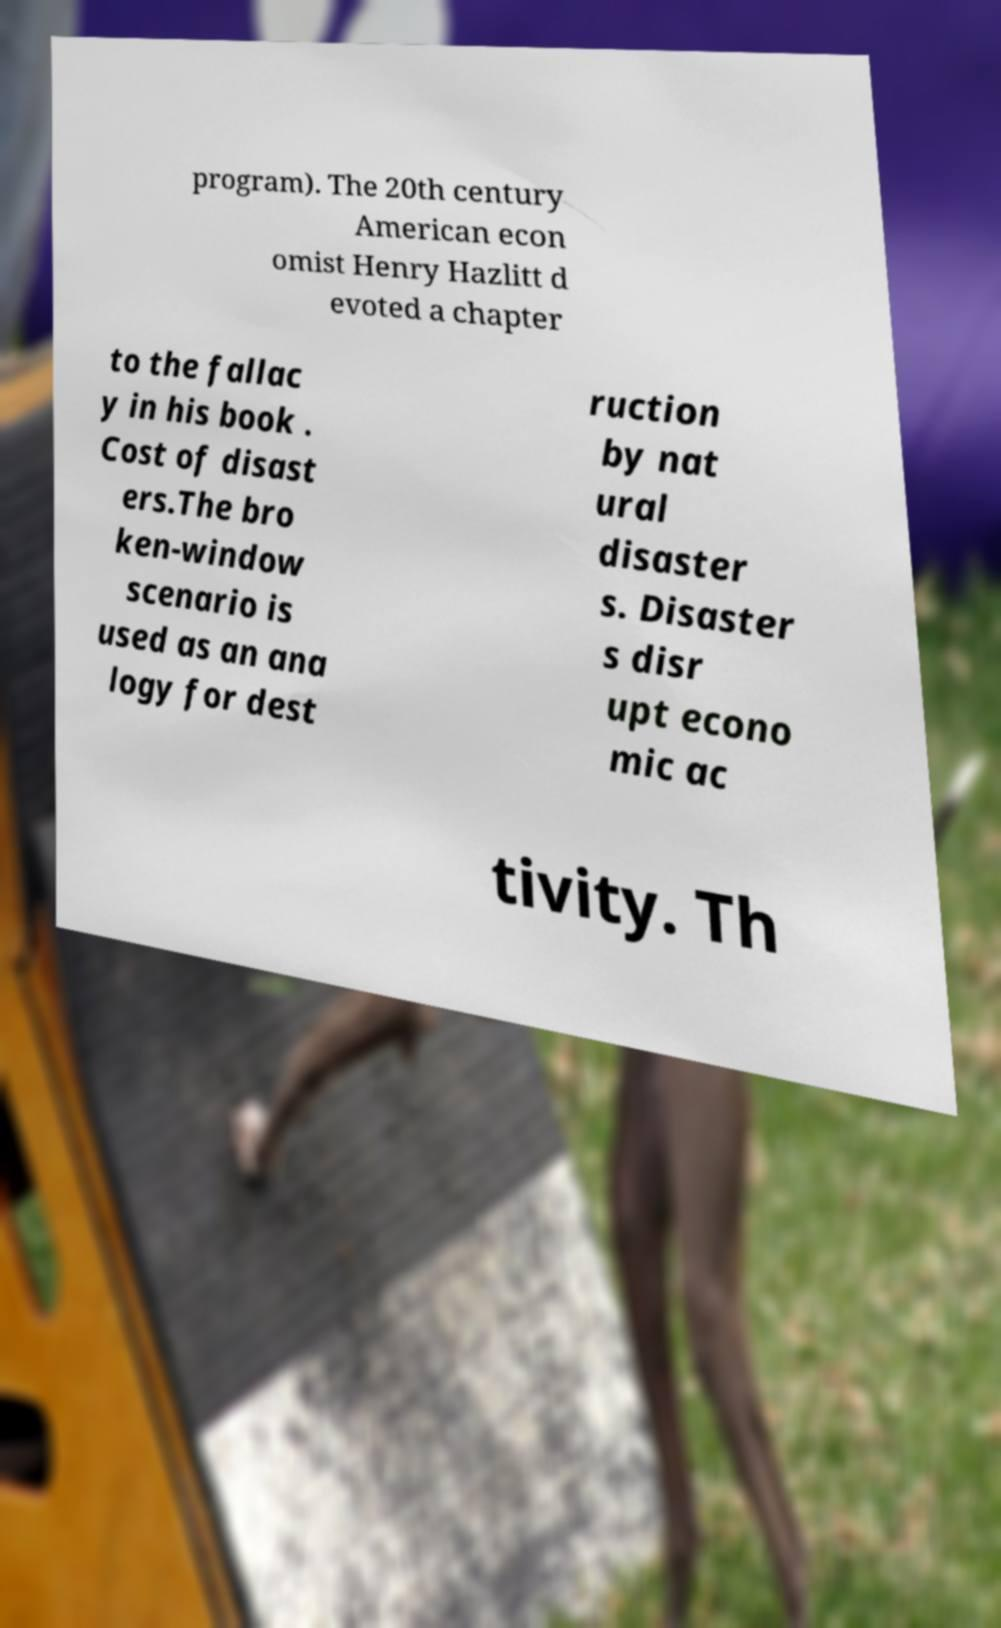I need the written content from this picture converted into text. Can you do that? program). The 20th century American econ omist Henry Hazlitt d evoted a chapter to the fallac y in his book . Cost of disast ers.The bro ken-window scenario is used as an ana logy for dest ruction by nat ural disaster s. Disaster s disr upt econo mic ac tivity. Th 